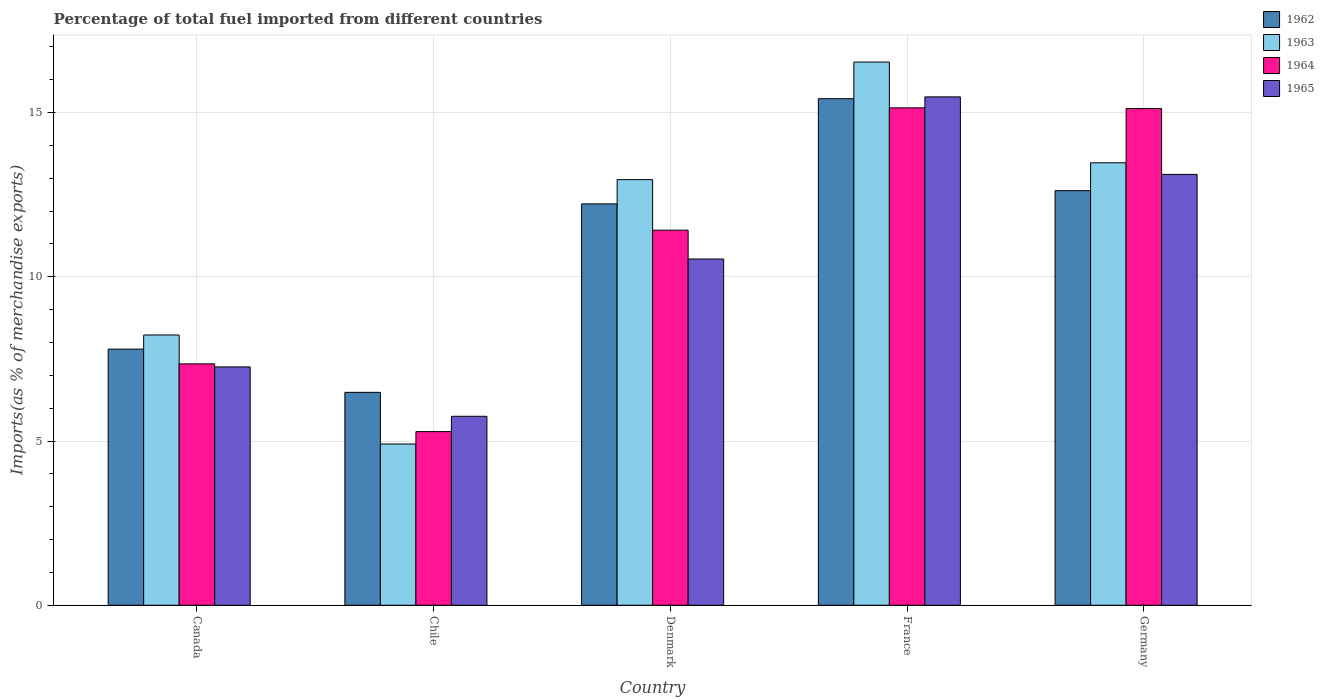How many groups of bars are there?
Provide a succinct answer. 5. Are the number of bars per tick equal to the number of legend labels?
Your answer should be compact. Yes. How many bars are there on the 1st tick from the left?
Give a very brief answer. 4. What is the label of the 5th group of bars from the left?
Ensure brevity in your answer.  Germany. In how many cases, is the number of bars for a given country not equal to the number of legend labels?
Your answer should be very brief. 0. What is the percentage of imports to different countries in 1963 in Chile?
Give a very brief answer. 4.91. Across all countries, what is the maximum percentage of imports to different countries in 1962?
Provide a succinct answer. 15.42. Across all countries, what is the minimum percentage of imports to different countries in 1964?
Give a very brief answer. 5.29. In which country was the percentage of imports to different countries in 1962 minimum?
Keep it short and to the point. Chile. What is the total percentage of imports to different countries in 1965 in the graph?
Make the answer very short. 52.14. What is the difference between the percentage of imports to different countries in 1962 in Canada and that in Denmark?
Make the answer very short. -4.42. What is the difference between the percentage of imports to different countries in 1965 in Denmark and the percentage of imports to different countries in 1963 in France?
Keep it short and to the point. -6. What is the average percentage of imports to different countries in 1965 per country?
Provide a succinct answer. 10.43. What is the difference between the percentage of imports to different countries of/in 1962 and percentage of imports to different countries of/in 1964 in Denmark?
Your answer should be compact. 0.8. In how many countries, is the percentage of imports to different countries in 1963 greater than 7 %?
Your response must be concise. 4. What is the ratio of the percentage of imports to different countries in 1962 in Canada to that in France?
Your response must be concise. 0.51. What is the difference between the highest and the second highest percentage of imports to different countries in 1965?
Offer a very short reply. -2.58. What is the difference between the highest and the lowest percentage of imports to different countries in 1962?
Offer a terse response. 8.94. Is the sum of the percentage of imports to different countries in 1964 in Canada and Germany greater than the maximum percentage of imports to different countries in 1962 across all countries?
Provide a short and direct response. Yes. Is it the case that in every country, the sum of the percentage of imports to different countries in 1964 and percentage of imports to different countries in 1962 is greater than the sum of percentage of imports to different countries in 1963 and percentage of imports to different countries in 1965?
Your answer should be very brief. No. What does the 1st bar from the left in Chile represents?
Ensure brevity in your answer.  1962. Is it the case that in every country, the sum of the percentage of imports to different countries in 1963 and percentage of imports to different countries in 1965 is greater than the percentage of imports to different countries in 1962?
Your answer should be very brief. Yes. Are all the bars in the graph horizontal?
Your response must be concise. No. Are the values on the major ticks of Y-axis written in scientific E-notation?
Provide a succinct answer. No. Does the graph contain any zero values?
Ensure brevity in your answer.  No. Does the graph contain grids?
Offer a very short reply. Yes. Where does the legend appear in the graph?
Provide a short and direct response. Top right. How many legend labels are there?
Keep it short and to the point. 4. What is the title of the graph?
Keep it short and to the point. Percentage of total fuel imported from different countries. Does "1971" appear as one of the legend labels in the graph?
Offer a very short reply. No. What is the label or title of the Y-axis?
Make the answer very short. Imports(as % of merchandise exports). What is the Imports(as % of merchandise exports) in 1962 in Canada?
Your answer should be compact. 7.8. What is the Imports(as % of merchandise exports) of 1963 in Canada?
Provide a succinct answer. 8.23. What is the Imports(as % of merchandise exports) in 1964 in Canada?
Give a very brief answer. 7.35. What is the Imports(as % of merchandise exports) of 1965 in Canada?
Provide a short and direct response. 7.26. What is the Imports(as % of merchandise exports) of 1962 in Chile?
Offer a terse response. 6.48. What is the Imports(as % of merchandise exports) in 1963 in Chile?
Provide a short and direct response. 4.91. What is the Imports(as % of merchandise exports) in 1964 in Chile?
Keep it short and to the point. 5.29. What is the Imports(as % of merchandise exports) of 1965 in Chile?
Your answer should be very brief. 5.75. What is the Imports(as % of merchandise exports) of 1962 in Denmark?
Your answer should be very brief. 12.22. What is the Imports(as % of merchandise exports) in 1963 in Denmark?
Your response must be concise. 12.96. What is the Imports(as % of merchandise exports) in 1964 in Denmark?
Provide a succinct answer. 11.42. What is the Imports(as % of merchandise exports) of 1965 in Denmark?
Provide a succinct answer. 10.54. What is the Imports(as % of merchandise exports) of 1962 in France?
Offer a terse response. 15.42. What is the Imports(as % of merchandise exports) of 1963 in France?
Your answer should be compact. 16.54. What is the Imports(as % of merchandise exports) in 1964 in France?
Give a very brief answer. 15.14. What is the Imports(as % of merchandise exports) of 1965 in France?
Your answer should be very brief. 15.48. What is the Imports(as % of merchandise exports) of 1962 in Germany?
Give a very brief answer. 12.62. What is the Imports(as % of merchandise exports) in 1963 in Germany?
Give a very brief answer. 13.47. What is the Imports(as % of merchandise exports) in 1964 in Germany?
Keep it short and to the point. 15.12. What is the Imports(as % of merchandise exports) in 1965 in Germany?
Make the answer very short. 13.12. Across all countries, what is the maximum Imports(as % of merchandise exports) of 1962?
Offer a very short reply. 15.42. Across all countries, what is the maximum Imports(as % of merchandise exports) of 1963?
Make the answer very short. 16.54. Across all countries, what is the maximum Imports(as % of merchandise exports) in 1964?
Give a very brief answer. 15.14. Across all countries, what is the maximum Imports(as % of merchandise exports) of 1965?
Make the answer very short. 15.48. Across all countries, what is the minimum Imports(as % of merchandise exports) in 1962?
Offer a terse response. 6.48. Across all countries, what is the minimum Imports(as % of merchandise exports) of 1963?
Ensure brevity in your answer.  4.91. Across all countries, what is the minimum Imports(as % of merchandise exports) of 1964?
Offer a terse response. 5.29. Across all countries, what is the minimum Imports(as % of merchandise exports) in 1965?
Offer a very short reply. 5.75. What is the total Imports(as % of merchandise exports) of 1962 in the graph?
Make the answer very short. 54.54. What is the total Imports(as % of merchandise exports) in 1963 in the graph?
Offer a very short reply. 56.1. What is the total Imports(as % of merchandise exports) in 1964 in the graph?
Provide a succinct answer. 54.32. What is the total Imports(as % of merchandise exports) of 1965 in the graph?
Your answer should be compact. 52.14. What is the difference between the Imports(as % of merchandise exports) of 1962 in Canada and that in Chile?
Offer a terse response. 1.32. What is the difference between the Imports(as % of merchandise exports) in 1963 in Canada and that in Chile?
Make the answer very short. 3.32. What is the difference between the Imports(as % of merchandise exports) in 1964 in Canada and that in Chile?
Provide a succinct answer. 2.06. What is the difference between the Imports(as % of merchandise exports) of 1965 in Canada and that in Chile?
Provide a short and direct response. 1.5. What is the difference between the Imports(as % of merchandise exports) of 1962 in Canada and that in Denmark?
Ensure brevity in your answer.  -4.42. What is the difference between the Imports(as % of merchandise exports) in 1963 in Canada and that in Denmark?
Give a very brief answer. -4.73. What is the difference between the Imports(as % of merchandise exports) of 1964 in Canada and that in Denmark?
Keep it short and to the point. -4.07. What is the difference between the Imports(as % of merchandise exports) in 1965 in Canada and that in Denmark?
Make the answer very short. -3.29. What is the difference between the Imports(as % of merchandise exports) in 1962 in Canada and that in France?
Ensure brevity in your answer.  -7.62. What is the difference between the Imports(as % of merchandise exports) in 1963 in Canada and that in France?
Your answer should be very brief. -8.31. What is the difference between the Imports(as % of merchandise exports) in 1964 in Canada and that in France?
Keep it short and to the point. -7.79. What is the difference between the Imports(as % of merchandise exports) in 1965 in Canada and that in France?
Ensure brevity in your answer.  -8.22. What is the difference between the Imports(as % of merchandise exports) in 1962 in Canada and that in Germany?
Keep it short and to the point. -4.82. What is the difference between the Imports(as % of merchandise exports) of 1963 in Canada and that in Germany?
Make the answer very short. -5.24. What is the difference between the Imports(as % of merchandise exports) in 1964 in Canada and that in Germany?
Your answer should be compact. -7.77. What is the difference between the Imports(as % of merchandise exports) in 1965 in Canada and that in Germany?
Ensure brevity in your answer.  -5.86. What is the difference between the Imports(as % of merchandise exports) of 1962 in Chile and that in Denmark?
Give a very brief answer. -5.74. What is the difference between the Imports(as % of merchandise exports) in 1963 in Chile and that in Denmark?
Offer a terse response. -8.05. What is the difference between the Imports(as % of merchandise exports) in 1964 in Chile and that in Denmark?
Your answer should be very brief. -6.13. What is the difference between the Imports(as % of merchandise exports) of 1965 in Chile and that in Denmark?
Your answer should be very brief. -4.79. What is the difference between the Imports(as % of merchandise exports) of 1962 in Chile and that in France?
Offer a very short reply. -8.94. What is the difference between the Imports(as % of merchandise exports) in 1963 in Chile and that in France?
Offer a very short reply. -11.63. What is the difference between the Imports(as % of merchandise exports) in 1964 in Chile and that in France?
Ensure brevity in your answer.  -9.86. What is the difference between the Imports(as % of merchandise exports) of 1965 in Chile and that in France?
Your answer should be very brief. -9.72. What is the difference between the Imports(as % of merchandise exports) of 1962 in Chile and that in Germany?
Your response must be concise. -6.14. What is the difference between the Imports(as % of merchandise exports) in 1963 in Chile and that in Germany?
Offer a very short reply. -8.56. What is the difference between the Imports(as % of merchandise exports) of 1964 in Chile and that in Germany?
Give a very brief answer. -9.83. What is the difference between the Imports(as % of merchandise exports) of 1965 in Chile and that in Germany?
Your answer should be compact. -7.36. What is the difference between the Imports(as % of merchandise exports) of 1962 in Denmark and that in France?
Your answer should be very brief. -3.2. What is the difference between the Imports(as % of merchandise exports) of 1963 in Denmark and that in France?
Your response must be concise. -3.58. What is the difference between the Imports(as % of merchandise exports) of 1964 in Denmark and that in France?
Offer a terse response. -3.72. What is the difference between the Imports(as % of merchandise exports) in 1965 in Denmark and that in France?
Ensure brevity in your answer.  -4.94. What is the difference between the Imports(as % of merchandise exports) of 1962 in Denmark and that in Germany?
Ensure brevity in your answer.  -0.4. What is the difference between the Imports(as % of merchandise exports) in 1963 in Denmark and that in Germany?
Your answer should be very brief. -0.51. What is the difference between the Imports(as % of merchandise exports) in 1964 in Denmark and that in Germany?
Your answer should be very brief. -3.7. What is the difference between the Imports(as % of merchandise exports) in 1965 in Denmark and that in Germany?
Give a very brief answer. -2.58. What is the difference between the Imports(as % of merchandise exports) in 1962 in France and that in Germany?
Your answer should be compact. 2.8. What is the difference between the Imports(as % of merchandise exports) in 1963 in France and that in Germany?
Offer a very short reply. 3.07. What is the difference between the Imports(as % of merchandise exports) of 1964 in France and that in Germany?
Offer a terse response. 0.02. What is the difference between the Imports(as % of merchandise exports) of 1965 in France and that in Germany?
Give a very brief answer. 2.36. What is the difference between the Imports(as % of merchandise exports) of 1962 in Canada and the Imports(as % of merchandise exports) of 1963 in Chile?
Ensure brevity in your answer.  2.89. What is the difference between the Imports(as % of merchandise exports) of 1962 in Canada and the Imports(as % of merchandise exports) of 1964 in Chile?
Provide a succinct answer. 2.51. What is the difference between the Imports(as % of merchandise exports) of 1962 in Canada and the Imports(as % of merchandise exports) of 1965 in Chile?
Make the answer very short. 2.04. What is the difference between the Imports(as % of merchandise exports) of 1963 in Canada and the Imports(as % of merchandise exports) of 1964 in Chile?
Offer a very short reply. 2.94. What is the difference between the Imports(as % of merchandise exports) of 1963 in Canada and the Imports(as % of merchandise exports) of 1965 in Chile?
Your answer should be compact. 2.48. What is the difference between the Imports(as % of merchandise exports) in 1964 in Canada and the Imports(as % of merchandise exports) in 1965 in Chile?
Keep it short and to the point. 1.6. What is the difference between the Imports(as % of merchandise exports) in 1962 in Canada and the Imports(as % of merchandise exports) in 1963 in Denmark?
Your response must be concise. -5.16. What is the difference between the Imports(as % of merchandise exports) in 1962 in Canada and the Imports(as % of merchandise exports) in 1964 in Denmark?
Provide a short and direct response. -3.62. What is the difference between the Imports(as % of merchandise exports) of 1962 in Canada and the Imports(as % of merchandise exports) of 1965 in Denmark?
Give a very brief answer. -2.74. What is the difference between the Imports(as % of merchandise exports) in 1963 in Canada and the Imports(as % of merchandise exports) in 1964 in Denmark?
Provide a short and direct response. -3.19. What is the difference between the Imports(as % of merchandise exports) of 1963 in Canada and the Imports(as % of merchandise exports) of 1965 in Denmark?
Your answer should be compact. -2.31. What is the difference between the Imports(as % of merchandise exports) of 1964 in Canada and the Imports(as % of merchandise exports) of 1965 in Denmark?
Keep it short and to the point. -3.19. What is the difference between the Imports(as % of merchandise exports) of 1962 in Canada and the Imports(as % of merchandise exports) of 1963 in France?
Make the answer very short. -8.74. What is the difference between the Imports(as % of merchandise exports) of 1962 in Canada and the Imports(as % of merchandise exports) of 1964 in France?
Give a very brief answer. -7.35. What is the difference between the Imports(as % of merchandise exports) of 1962 in Canada and the Imports(as % of merchandise exports) of 1965 in France?
Give a very brief answer. -7.68. What is the difference between the Imports(as % of merchandise exports) of 1963 in Canada and the Imports(as % of merchandise exports) of 1964 in France?
Provide a succinct answer. -6.91. What is the difference between the Imports(as % of merchandise exports) of 1963 in Canada and the Imports(as % of merchandise exports) of 1965 in France?
Offer a very short reply. -7.25. What is the difference between the Imports(as % of merchandise exports) of 1964 in Canada and the Imports(as % of merchandise exports) of 1965 in France?
Provide a short and direct response. -8.13. What is the difference between the Imports(as % of merchandise exports) of 1962 in Canada and the Imports(as % of merchandise exports) of 1963 in Germany?
Offer a terse response. -5.67. What is the difference between the Imports(as % of merchandise exports) of 1962 in Canada and the Imports(as % of merchandise exports) of 1964 in Germany?
Your response must be concise. -7.32. What is the difference between the Imports(as % of merchandise exports) in 1962 in Canada and the Imports(as % of merchandise exports) in 1965 in Germany?
Your response must be concise. -5.32. What is the difference between the Imports(as % of merchandise exports) in 1963 in Canada and the Imports(as % of merchandise exports) in 1964 in Germany?
Offer a terse response. -6.89. What is the difference between the Imports(as % of merchandise exports) of 1963 in Canada and the Imports(as % of merchandise exports) of 1965 in Germany?
Make the answer very short. -4.89. What is the difference between the Imports(as % of merchandise exports) in 1964 in Canada and the Imports(as % of merchandise exports) in 1965 in Germany?
Your answer should be compact. -5.77. What is the difference between the Imports(as % of merchandise exports) in 1962 in Chile and the Imports(as % of merchandise exports) in 1963 in Denmark?
Provide a short and direct response. -6.48. What is the difference between the Imports(as % of merchandise exports) in 1962 in Chile and the Imports(as % of merchandise exports) in 1964 in Denmark?
Keep it short and to the point. -4.94. What is the difference between the Imports(as % of merchandise exports) of 1962 in Chile and the Imports(as % of merchandise exports) of 1965 in Denmark?
Keep it short and to the point. -4.06. What is the difference between the Imports(as % of merchandise exports) of 1963 in Chile and the Imports(as % of merchandise exports) of 1964 in Denmark?
Offer a very short reply. -6.51. What is the difference between the Imports(as % of merchandise exports) of 1963 in Chile and the Imports(as % of merchandise exports) of 1965 in Denmark?
Provide a short and direct response. -5.63. What is the difference between the Imports(as % of merchandise exports) of 1964 in Chile and the Imports(as % of merchandise exports) of 1965 in Denmark?
Provide a succinct answer. -5.25. What is the difference between the Imports(as % of merchandise exports) in 1962 in Chile and the Imports(as % of merchandise exports) in 1963 in France?
Your answer should be very brief. -10.06. What is the difference between the Imports(as % of merchandise exports) of 1962 in Chile and the Imports(as % of merchandise exports) of 1964 in France?
Offer a terse response. -8.66. What is the difference between the Imports(as % of merchandise exports) in 1962 in Chile and the Imports(as % of merchandise exports) in 1965 in France?
Provide a short and direct response. -9. What is the difference between the Imports(as % of merchandise exports) in 1963 in Chile and the Imports(as % of merchandise exports) in 1964 in France?
Your answer should be very brief. -10.23. What is the difference between the Imports(as % of merchandise exports) in 1963 in Chile and the Imports(as % of merchandise exports) in 1965 in France?
Offer a very short reply. -10.57. What is the difference between the Imports(as % of merchandise exports) of 1964 in Chile and the Imports(as % of merchandise exports) of 1965 in France?
Make the answer very short. -10.19. What is the difference between the Imports(as % of merchandise exports) in 1962 in Chile and the Imports(as % of merchandise exports) in 1963 in Germany?
Provide a short and direct response. -6.99. What is the difference between the Imports(as % of merchandise exports) in 1962 in Chile and the Imports(as % of merchandise exports) in 1964 in Germany?
Provide a succinct answer. -8.64. What is the difference between the Imports(as % of merchandise exports) of 1962 in Chile and the Imports(as % of merchandise exports) of 1965 in Germany?
Provide a succinct answer. -6.64. What is the difference between the Imports(as % of merchandise exports) in 1963 in Chile and the Imports(as % of merchandise exports) in 1964 in Germany?
Make the answer very short. -10.21. What is the difference between the Imports(as % of merchandise exports) in 1963 in Chile and the Imports(as % of merchandise exports) in 1965 in Germany?
Make the answer very short. -8.21. What is the difference between the Imports(as % of merchandise exports) in 1964 in Chile and the Imports(as % of merchandise exports) in 1965 in Germany?
Give a very brief answer. -7.83. What is the difference between the Imports(as % of merchandise exports) in 1962 in Denmark and the Imports(as % of merchandise exports) in 1963 in France?
Ensure brevity in your answer.  -4.32. What is the difference between the Imports(as % of merchandise exports) of 1962 in Denmark and the Imports(as % of merchandise exports) of 1964 in France?
Offer a very short reply. -2.92. What is the difference between the Imports(as % of merchandise exports) in 1962 in Denmark and the Imports(as % of merchandise exports) in 1965 in France?
Give a very brief answer. -3.26. What is the difference between the Imports(as % of merchandise exports) in 1963 in Denmark and the Imports(as % of merchandise exports) in 1964 in France?
Offer a very short reply. -2.19. What is the difference between the Imports(as % of merchandise exports) in 1963 in Denmark and the Imports(as % of merchandise exports) in 1965 in France?
Provide a succinct answer. -2.52. What is the difference between the Imports(as % of merchandise exports) of 1964 in Denmark and the Imports(as % of merchandise exports) of 1965 in France?
Make the answer very short. -4.06. What is the difference between the Imports(as % of merchandise exports) of 1962 in Denmark and the Imports(as % of merchandise exports) of 1963 in Germany?
Provide a succinct answer. -1.25. What is the difference between the Imports(as % of merchandise exports) in 1962 in Denmark and the Imports(as % of merchandise exports) in 1964 in Germany?
Provide a succinct answer. -2.9. What is the difference between the Imports(as % of merchandise exports) in 1962 in Denmark and the Imports(as % of merchandise exports) in 1965 in Germany?
Provide a succinct answer. -0.9. What is the difference between the Imports(as % of merchandise exports) of 1963 in Denmark and the Imports(as % of merchandise exports) of 1964 in Germany?
Provide a succinct answer. -2.16. What is the difference between the Imports(as % of merchandise exports) in 1963 in Denmark and the Imports(as % of merchandise exports) in 1965 in Germany?
Provide a succinct answer. -0.16. What is the difference between the Imports(as % of merchandise exports) of 1964 in Denmark and the Imports(as % of merchandise exports) of 1965 in Germany?
Your answer should be very brief. -1.7. What is the difference between the Imports(as % of merchandise exports) of 1962 in France and the Imports(as % of merchandise exports) of 1963 in Germany?
Your answer should be compact. 1.95. What is the difference between the Imports(as % of merchandise exports) in 1962 in France and the Imports(as % of merchandise exports) in 1964 in Germany?
Your response must be concise. 0.3. What is the difference between the Imports(as % of merchandise exports) of 1962 in France and the Imports(as % of merchandise exports) of 1965 in Germany?
Your response must be concise. 2.31. What is the difference between the Imports(as % of merchandise exports) in 1963 in France and the Imports(as % of merchandise exports) in 1964 in Germany?
Ensure brevity in your answer.  1.42. What is the difference between the Imports(as % of merchandise exports) in 1963 in France and the Imports(as % of merchandise exports) in 1965 in Germany?
Offer a terse response. 3.42. What is the difference between the Imports(as % of merchandise exports) of 1964 in France and the Imports(as % of merchandise exports) of 1965 in Germany?
Provide a short and direct response. 2.03. What is the average Imports(as % of merchandise exports) of 1962 per country?
Offer a very short reply. 10.91. What is the average Imports(as % of merchandise exports) of 1963 per country?
Your response must be concise. 11.22. What is the average Imports(as % of merchandise exports) in 1964 per country?
Keep it short and to the point. 10.86. What is the average Imports(as % of merchandise exports) in 1965 per country?
Offer a very short reply. 10.43. What is the difference between the Imports(as % of merchandise exports) in 1962 and Imports(as % of merchandise exports) in 1963 in Canada?
Give a very brief answer. -0.43. What is the difference between the Imports(as % of merchandise exports) of 1962 and Imports(as % of merchandise exports) of 1964 in Canada?
Ensure brevity in your answer.  0.45. What is the difference between the Imports(as % of merchandise exports) in 1962 and Imports(as % of merchandise exports) in 1965 in Canada?
Offer a very short reply. 0.54. What is the difference between the Imports(as % of merchandise exports) in 1963 and Imports(as % of merchandise exports) in 1964 in Canada?
Your answer should be compact. 0.88. What is the difference between the Imports(as % of merchandise exports) of 1963 and Imports(as % of merchandise exports) of 1965 in Canada?
Offer a very short reply. 0.97. What is the difference between the Imports(as % of merchandise exports) of 1964 and Imports(as % of merchandise exports) of 1965 in Canada?
Provide a short and direct response. 0.09. What is the difference between the Imports(as % of merchandise exports) in 1962 and Imports(as % of merchandise exports) in 1963 in Chile?
Give a very brief answer. 1.57. What is the difference between the Imports(as % of merchandise exports) of 1962 and Imports(as % of merchandise exports) of 1964 in Chile?
Your answer should be very brief. 1.19. What is the difference between the Imports(as % of merchandise exports) of 1962 and Imports(as % of merchandise exports) of 1965 in Chile?
Ensure brevity in your answer.  0.73. What is the difference between the Imports(as % of merchandise exports) in 1963 and Imports(as % of merchandise exports) in 1964 in Chile?
Your answer should be very brief. -0.38. What is the difference between the Imports(as % of merchandise exports) of 1963 and Imports(as % of merchandise exports) of 1965 in Chile?
Ensure brevity in your answer.  -0.84. What is the difference between the Imports(as % of merchandise exports) of 1964 and Imports(as % of merchandise exports) of 1965 in Chile?
Your response must be concise. -0.47. What is the difference between the Imports(as % of merchandise exports) of 1962 and Imports(as % of merchandise exports) of 1963 in Denmark?
Give a very brief answer. -0.74. What is the difference between the Imports(as % of merchandise exports) of 1962 and Imports(as % of merchandise exports) of 1964 in Denmark?
Provide a succinct answer. 0.8. What is the difference between the Imports(as % of merchandise exports) of 1962 and Imports(as % of merchandise exports) of 1965 in Denmark?
Your answer should be very brief. 1.68. What is the difference between the Imports(as % of merchandise exports) of 1963 and Imports(as % of merchandise exports) of 1964 in Denmark?
Keep it short and to the point. 1.54. What is the difference between the Imports(as % of merchandise exports) of 1963 and Imports(as % of merchandise exports) of 1965 in Denmark?
Provide a short and direct response. 2.42. What is the difference between the Imports(as % of merchandise exports) of 1964 and Imports(as % of merchandise exports) of 1965 in Denmark?
Offer a terse response. 0.88. What is the difference between the Imports(as % of merchandise exports) in 1962 and Imports(as % of merchandise exports) in 1963 in France?
Your answer should be very brief. -1.12. What is the difference between the Imports(as % of merchandise exports) in 1962 and Imports(as % of merchandise exports) in 1964 in France?
Your answer should be compact. 0.28. What is the difference between the Imports(as % of merchandise exports) of 1962 and Imports(as % of merchandise exports) of 1965 in France?
Give a very brief answer. -0.05. What is the difference between the Imports(as % of merchandise exports) in 1963 and Imports(as % of merchandise exports) in 1964 in France?
Make the answer very short. 1.39. What is the difference between the Imports(as % of merchandise exports) in 1963 and Imports(as % of merchandise exports) in 1965 in France?
Provide a short and direct response. 1.06. What is the difference between the Imports(as % of merchandise exports) of 1964 and Imports(as % of merchandise exports) of 1965 in France?
Offer a terse response. -0.33. What is the difference between the Imports(as % of merchandise exports) of 1962 and Imports(as % of merchandise exports) of 1963 in Germany?
Your answer should be compact. -0.85. What is the difference between the Imports(as % of merchandise exports) in 1962 and Imports(as % of merchandise exports) in 1964 in Germany?
Your answer should be very brief. -2.5. What is the difference between the Imports(as % of merchandise exports) in 1962 and Imports(as % of merchandise exports) in 1965 in Germany?
Keep it short and to the point. -0.49. What is the difference between the Imports(as % of merchandise exports) of 1963 and Imports(as % of merchandise exports) of 1964 in Germany?
Give a very brief answer. -1.65. What is the difference between the Imports(as % of merchandise exports) of 1963 and Imports(as % of merchandise exports) of 1965 in Germany?
Provide a short and direct response. 0.35. What is the difference between the Imports(as % of merchandise exports) of 1964 and Imports(as % of merchandise exports) of 1965 in Germany?
Your response must be concise. 2. What is the ratio of the Imports(as % of merchandise exports) in 1962 in Canada to that in Chile?
Your answer should be compact. 1.2. What is the ratio of the Imports(as % of merchandise exports) in 1963 in Canada to that in Chile?
Offer a very short reply. 1.68. What is the ratio of the Imports(as % of merchandise exports) of 1964 in Canada to that in Chile?
Provide a succinct answer. 1.39. What is the ratio of the Imports(as % of merchandise exports) in 1965 in Canada to that in Chile?
Your response must be concise. 1.26. What is the ratio of the Imports(as % of merchandise exports) in 1962 in Canada to that in Denmark?
Your answer should be compact. 0.64. What is the ratio of the Imports(as % of merchandise exports) of 1963 in Canada to that in Denmark?
Make the answer very short. 0.64. What is the ratio of the Imports(as % of merchandise exports) of 1964 in Canada to that in Denmark?
Your response must be concise. 0.64. What is the ratio of the Imports(as % of merchandise exports) of 1965 in Canada to that in Denmark?
Give a very brief answer. 0.69. What is the ratio of the Imports(as % of merchandise exports) of 1962 in Canada to that in France?
Ensure brevity in your answer.  0.51. What is the ratio of the Imports(as % of merchandise exports) of 1963 in Canada to that in France?
Provide a short and direct response. 0.5. What is the ratio of the Imports(as % of merchandise exports) in 1964 in Canada to that in France?
Offer a terse response. 0.49. What is the ratio of the Imports(as % of merchandise exports) of 1965 in Canada to that in France?
Your answer should be compact. 0.47. What is the ratio of the Imports(as % of merchandise exports) in 1962 in Canada to that in Germany?
Provide a succinct answer. 0.62. What is the ratio of the Imports(as % of merchandise exports) of 1963 in Canada to that in Germany?
Offer a very short reply. 0.61. What is the ratio of the Imports(as % of merchandise exports) in 1964 in Canada to that in Germany?
Offer a terse response. 0.49. What is the ratio of the Imports(as % of merchandise exports) in 1965 in Canada to that in Germany?
Provide a short and direct response. 0.55. What is the ratio of the Imports(as % of merchandise exports) in 1962 in Chile to that in Denmark?
Offer a very short reply. 0.53. What is the ratio of the Imports(as % of merchandise exports) of 1963 in Chile to that in Denmark?
Offer a very short reply. 0.38. What is the ratio of the Imports(as % of merchandise exports) in 1964 in Chile to that in Denmark?
Your answer should be very brief. 0.46. What is the ratio of the Imports(as % of merchandise exports) of 1965 in Chile to that in Denmark?
Ensure brevity in your answer.  0.55. What is the ratio of the Imports(as % of merchandise exports) of 1962 in Chile to that in France?
Your answer should be very brief. 0.42. What is the ratio of the Imports(as % of merchandise exports) of 1963 in Chile to that in France?
Your answer should be very brief. 0.3. What is the ratio of the Imports(as % of merchandise exports) of 1964 in Chile to that in France?
Your response must be concise. 0.35. What is the ratio of the Imports(as % of merchandise exports) in 1965 in Chile to that in France?
Provide a succinct answer. 0.37. What is the ratio of the Imports(as % of merchandise exports) of 1962 in Chile to that in Germany?
Give a very brief answer. 0.51. What is the ratio of the Imports(as % of merchandise exports) in 1963 in Chile to that in Germany?
Keep it short and to the point. 0.36. What is the ratio of the Imports(as % of merchandise exports) of 1964 in Chile to that in Germany?
Make the answer very short. 0.35. What is the ratio of the Imports(as % of merchandise exports) in 1965 in Chile to that in Germany?
Offer a very short reply. 0.44. What is the ratio of the Imports(as % of merchandise exports) of 1962 in Denmark to that in France?
Your answer should be compact. 0.79. What is the ratio of the Imports(as % of merchandise exports) in 1963 in Denmark to that in France?
Ensure brevity in your answer.  0.78. What is the ratio of the Imports(as % of merchandise exports) of 1964 in Denmark to that in France?
Give a very brief answer. 0.75. What is the ratio of the Imports(as % of merchandise exports) in 1965 in Denmark to that in France?
Your response must be concise. 0.68. What is the ratio of the Imports(as % of merchandise exports) in 1963 in Denmark to that in Germany?
Your response must be concise. 0.96. What is the ratio of the Imports(as % of merchandise exports) in 1964 in Denmark to that in Germany?
Ensure brevity in your answer.  0.76. What is the ratio of the Imports(as % of merchandise exports) in 1965 in Denmark to that in Germany?
Your response must be concise. 0.8. What is the ratio of the Imports(as % of merchandise exports) of 1962 in France to that in Germany?
Your response must be concise. 1.22. What is the ratio of the Imports(as % of merchandise exports) of 1963 in France to that in Germany?
Make the answer very short. 1.23. What is the ratio of the Imports(as % of merchandise exports) of 1965 in France to that in Germany?
Make the answer very short. 1.18. What is the difference between the highest and the second highest Imports(as % of merchandise exports) of 1962?
Your answer should be compact. 2.8. What is the difference between the highest and the second highest Imports(as % of merchandise exports) in 1963?
Make the answer very short. 3.07. What is the difference between the highest and the second highest Imports(as % of merchandise exports) in 1964?
Offer a terse response. 0.02. What is the difference between the highest and the second highest Imports(as % of merchandise exports) of 1965?
Your answer should be compact. 2.36. What is the difference between the highest and the lowest Imports(as % of merchandise exports) of 1962?
Ensure brevity in your answer.  8.94. What is the difference between the highest and the lowest Imports(as % of merchandise exports) of 1963?
Make the answer very short. 11.63. What is the difference between the highest and the lowest Imports(as % of merchandise exports) of 1964?
Ensure brevity in your answer.  9.86. What is the difference between the highest and the lowest Imports(as % of merchandise exports) in 1965?
Your response must be concise. 9.72. 